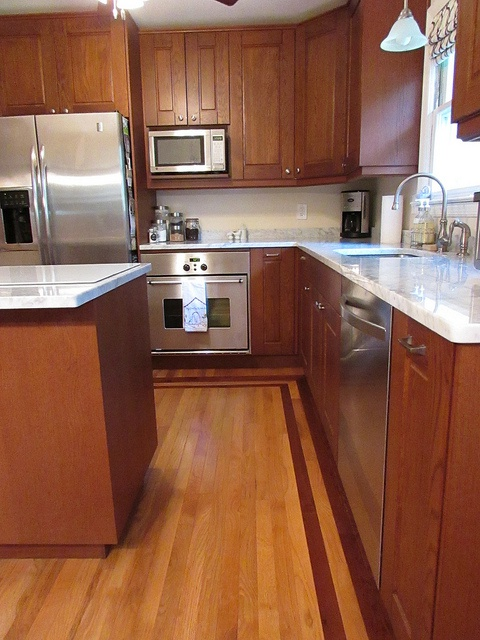Describe the objects in this image and their specific colors. I can see refrigerator in darkgray, gray, lightgray, and tan tones, oven in darkgray, gray, white, maroon, and black tones, microwave in darkgray, white, gray, and black tones, and sink in darkgray, lightblue, and gray tones in this image. 